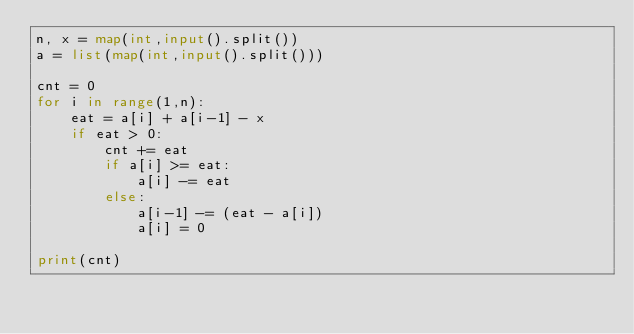<code> <loc_0><loc_0><loc_500><loc_500><_Python_>n, x = map(int,input().split())
a = list(map(int,input().split()))

cnt = 0
for i in range(1,n):
    eat = a[i] + a[i-1] - x
    if eat > 0:
        cnt += eat
        if a[i] >= eat:
            a[i] -= eat
        else:
            a[i-1] -= (eat - a[i])
            a[i] = 0

print(cnt)</code> 